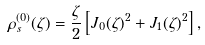<formula> <loc_0><loc_0><loc_500><loc_500>\rho _ { s } ^ { ( 0 ) } ( \zeta ) = \frac { \zeta } { 2 } \left [ J _ { 0 } ( \zeta ) ^ { 2 } + J _ { 1 } ( \zeta ) ^ { 2 } \right ] ,</formula> 